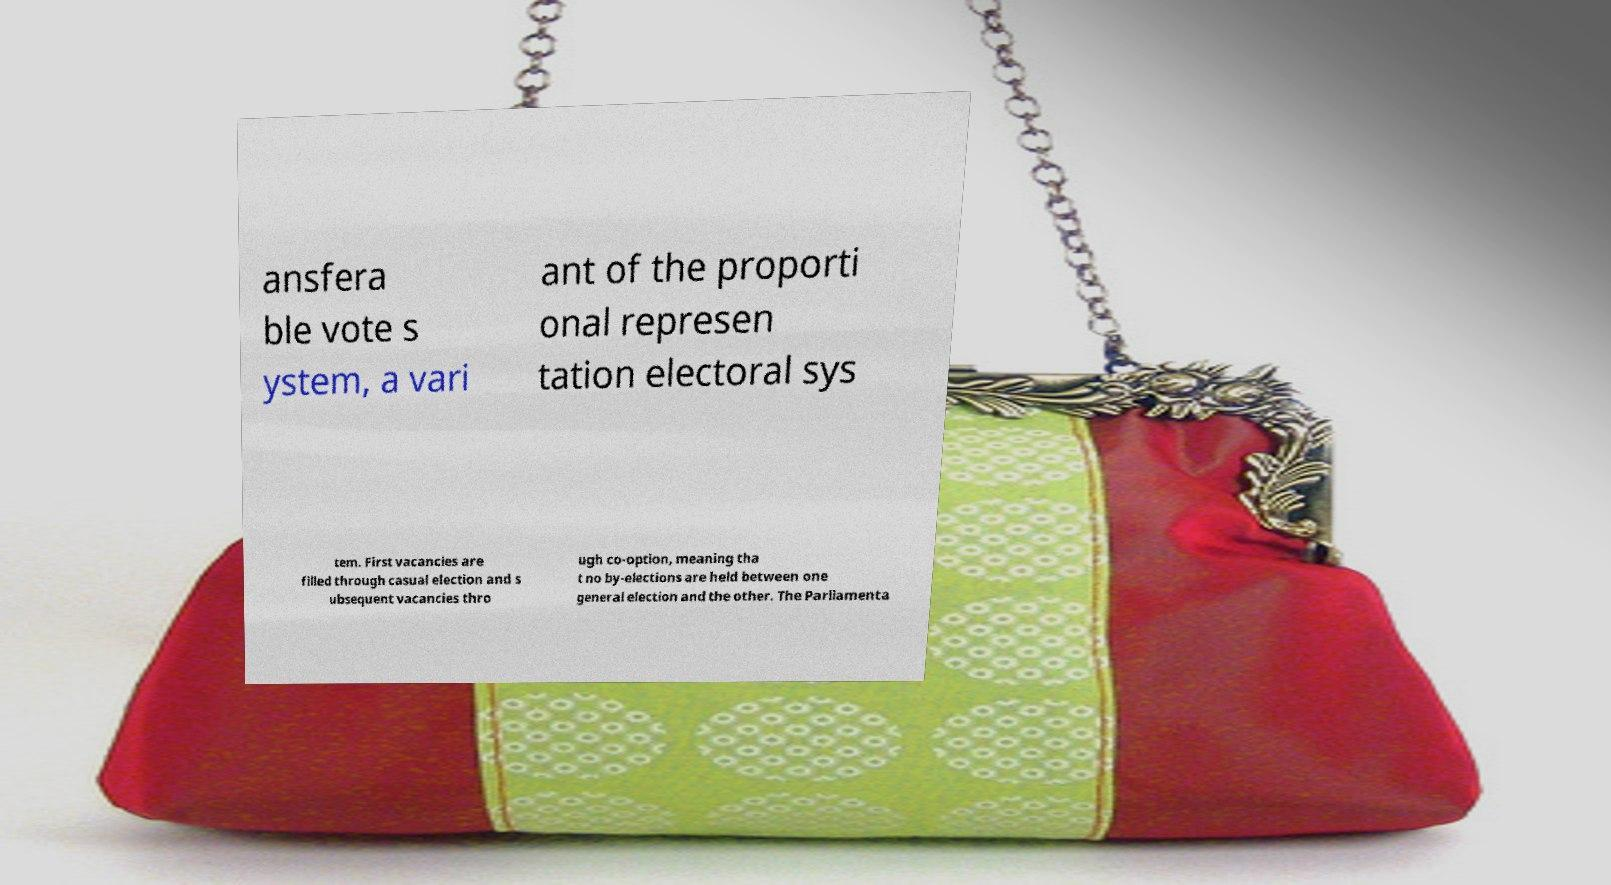Could you assist in decoding the text presented in this image and type it out clearly? ansfera ble vote s ystem, a vari ant of the proporti onal represen tation electoral sys tem. First vacancies are filled through casual election and s ubsequent vacancies thro ugh co-option, meaning tha t no by-elections are held between one general election and the other. The Parliamenta 